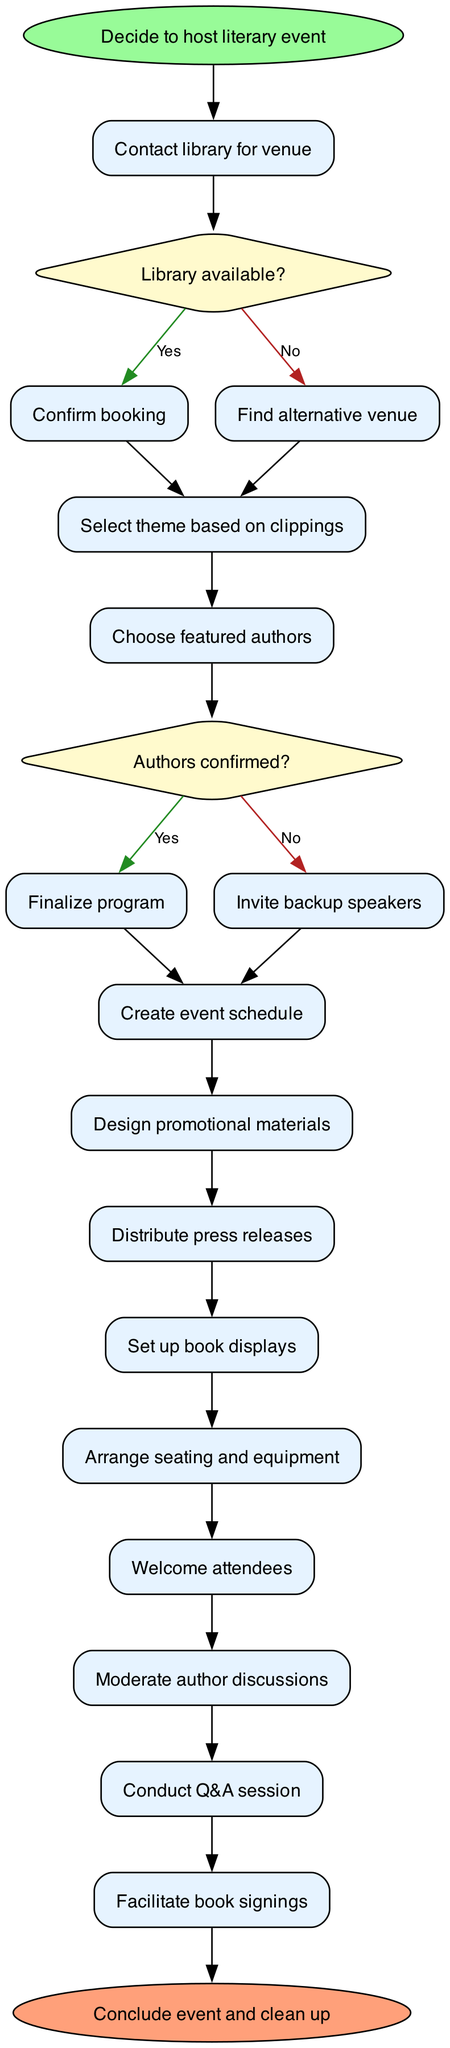What is the starting node of the diagram? The diagram begins with the "Decide to host literary event" node, which indicates the initiation of the process.
Answer: Decide to host literary event How many activities are listed in the diagram? By counting the activities mentioned in the diagram, there are a total of 11 distinct activities outlined.
Answer: 11 What decision follows contacting the library? After "Contact library for venue," the next step involves deciding if the library is available, which is represented by the decision node regarding library availability.
Answer: Library available? What is the final step before concluding the event? The last activity detailed before the end of the diagram is "Facilitate book signings," which indicates that this occurs right before the event concludes and cleanup begins.
Answer: Facilitate book signings Which activity directly follows confirming authors? Upon confirming authors, the next step in the process is to "Finalize program," which is a necessary action before moving on with the event planning.
Answer: Finalize program What happens if the library is not available? If the library is not available, the diagram indicates that the next action is to "Find alternative venue" as a response to this decision node.
Answer: Find alternative venue How does the diagram indicate the completion of the event? The completion of the event is signified by reaching the end node labeled "Conclude event and clean up," which signifies the event has concluded.
Answer: Conclude event and clean up What is the relationship between "Choose featured authors" and "Finalize program"? "Choose featured authors" leads directly to the decision node about author confirmation, and upon confirmation, it flows to "Finalize program," establishing a sequential relationship.
Answer: Choose featured authors → Finalize program What type of node represents decisions in the diagram? The decisions within the diagram are represented by diamond-shaped nodes, which are characteristically used to indicate points of choice or branching paths.
Answer: Diamond-shaped nodes 